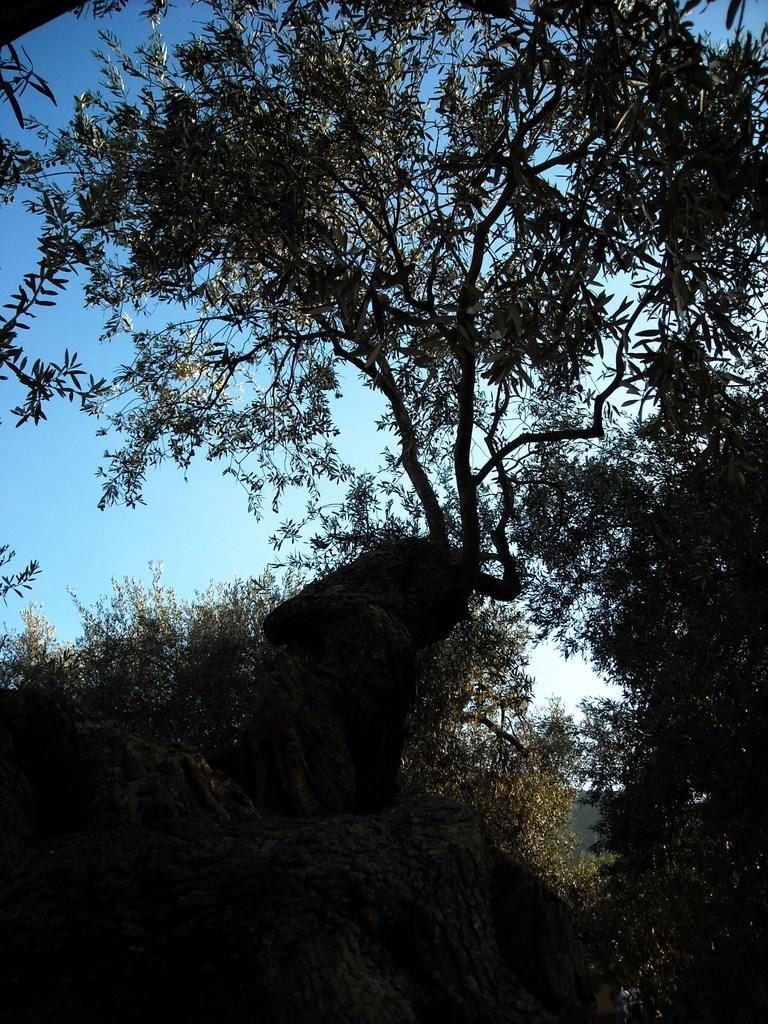What type of vegetation can be seen in the image? There are trees in the image. What is the opinion of the donkey about the recess in the image? There is no donkey or recess present in the image, so it is not possible to determine the opinion of a donkey about a recess. 